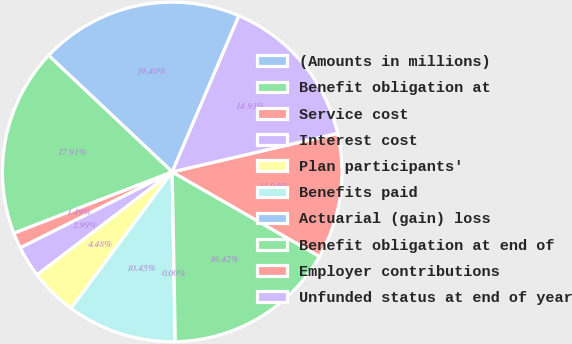Convert chart to OTSL. <chart><loc_0><loc_0><loc_500><loc_500><pie_chart><fcel>(Amounts in millions)<fcel>Benefit obligation at<fcel>Service cost<fcel>Interest cost<fcel>Plan participants'<fcel>Benefits paid<fcel>Actuarial (gain) loss<fcel>Benefit obligation at end of<fcel>Employer contributions<fcel>Unfunded status at end of year<nl><fcel>19.4%<fcel>17.91%<fcel>1.49%<fcel>2.99%<fcel>4.48%<fcel>10.45%<fcel>0.0%<fcel>16.42%<fcel>11.94%<fcel>14.93%<nl></chart> 